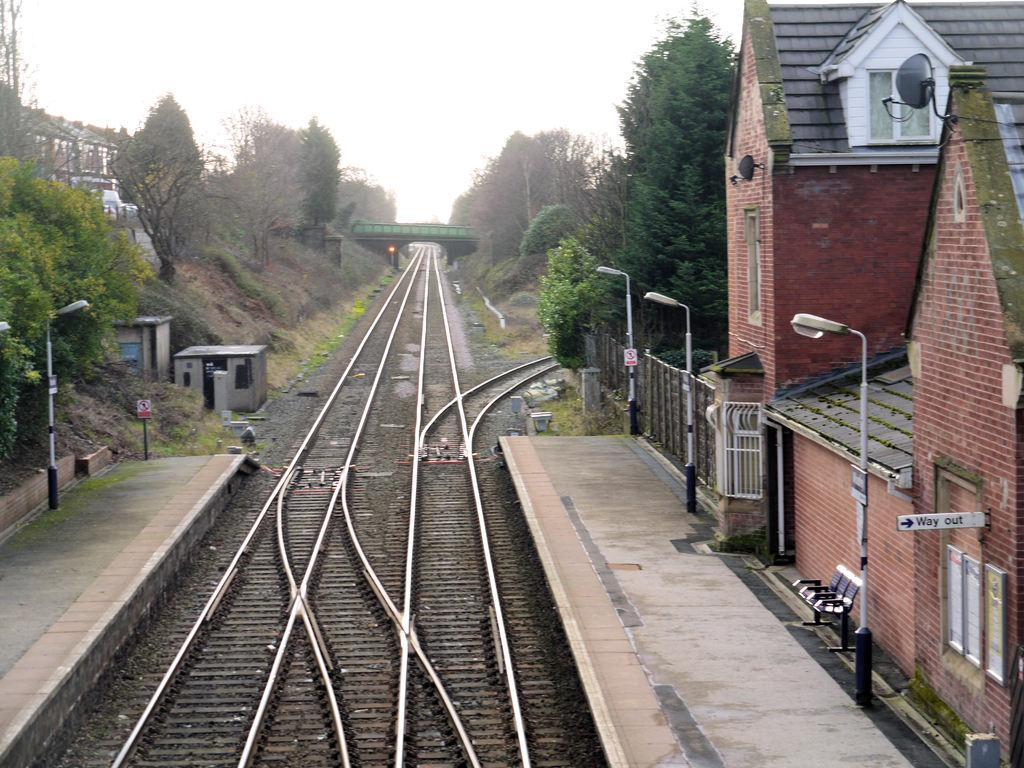What is located in the center of the image? There are railway tracks in the center of the image. What structure can be seen in the image? There is a bridge in the image. What can be found on the right side of the image? There are sheds and poles on the right side of the image. What is visible in the background of the image? There are trees and sky visible in the background of the image. What might someone use to sit and rest in the image? There is a bench in the image. What type of pest can be seen crawling on the railway tracks in the image? There are no pests visible on the railway tracks in the image. What color is the smoke coming from the bridge in the image? There is no smoke coming from the bridge in the image. 